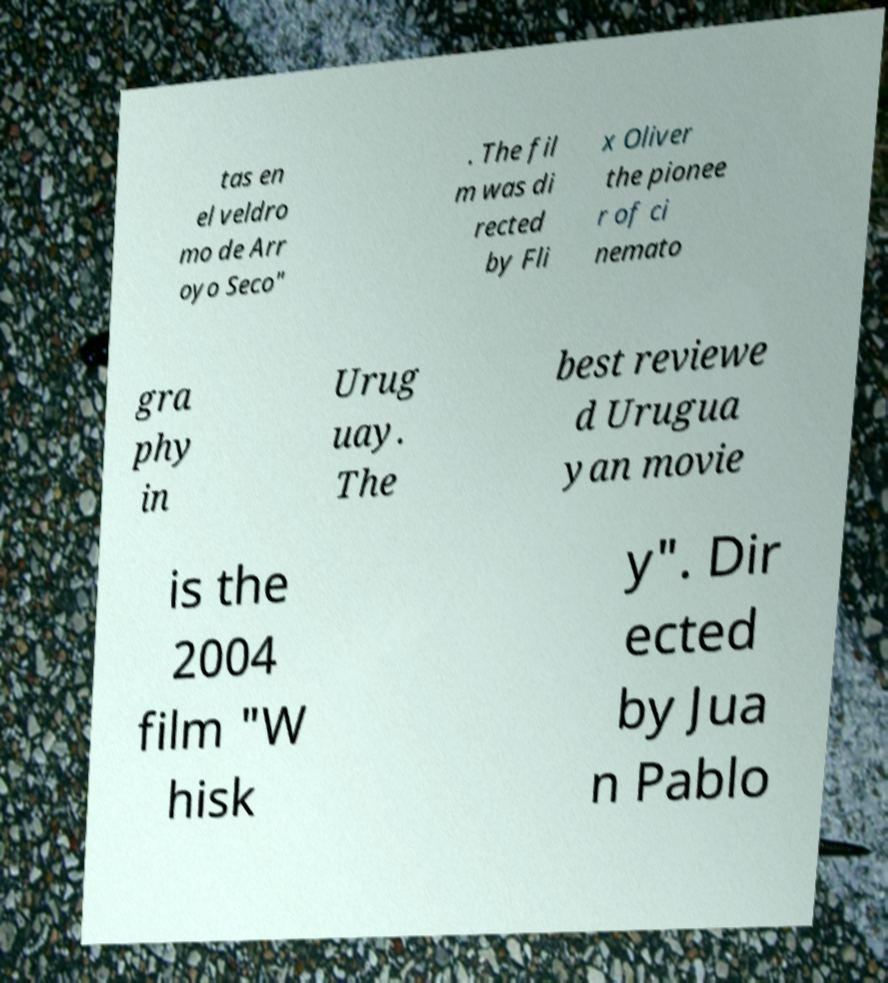I need the written content from this picture converted into text. Can you do that? tas en el veldro mo de Arr oyo Seco" . The fil m was di rected by Fli x Oliver the pionee r of ci nemato gra phy in Urug uay. The best reviewe d Urugua yan movie is the 2004 film "W hisk y". Dir ected by Jua n Pablo 